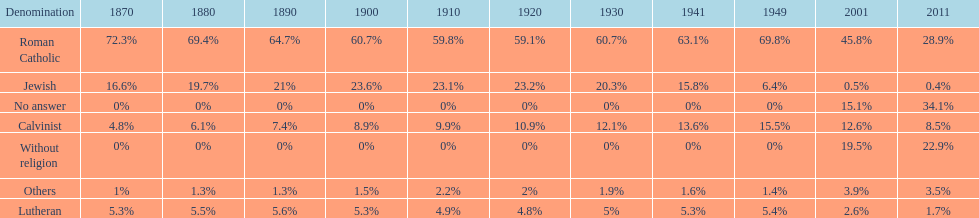Which denomination has the highest margin? Roman Catholic. 